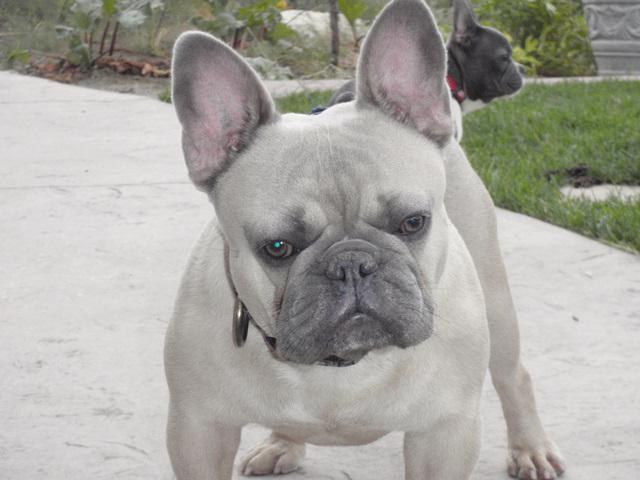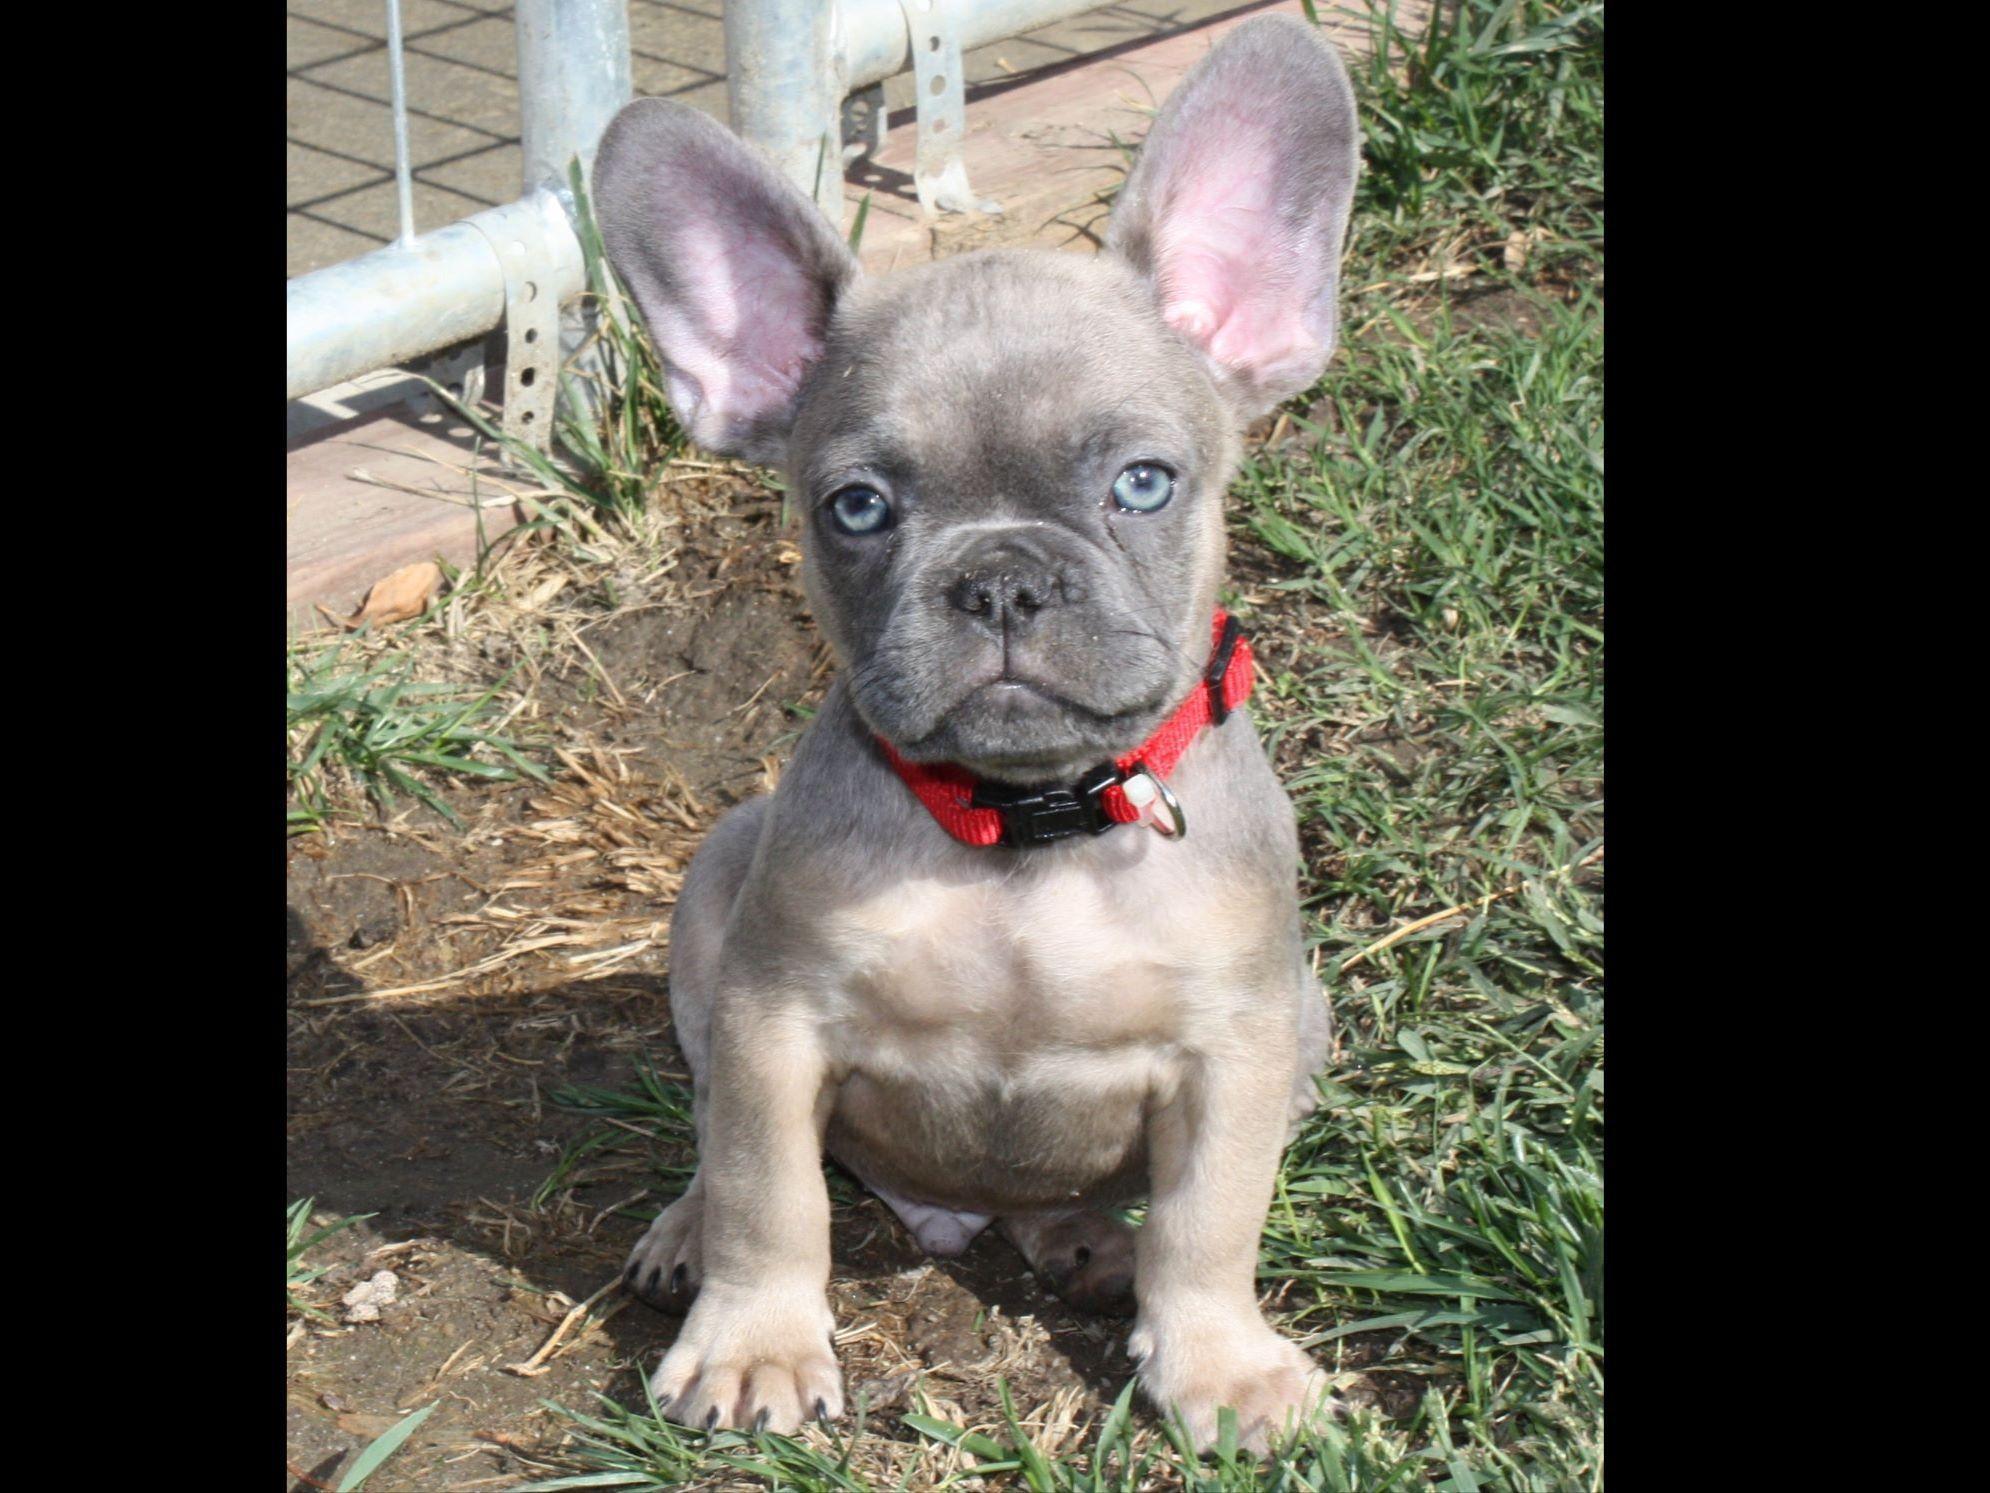The first image is the image on the left, the second image is the image on the right. Assess this claim about the two images: "The right image shows a big-eared dog with light blue eyes, and the left image shows a dog standing on all fours with its body turned forward.". Correct or not? Answer yes or no. Yes. The first image is the image on the left, the second image is the image on the right. Examine the images to the left and right. Is the description "There are exactly two french bulldogs that are located outdoors." accurate? Answer yes or no. Yes. 